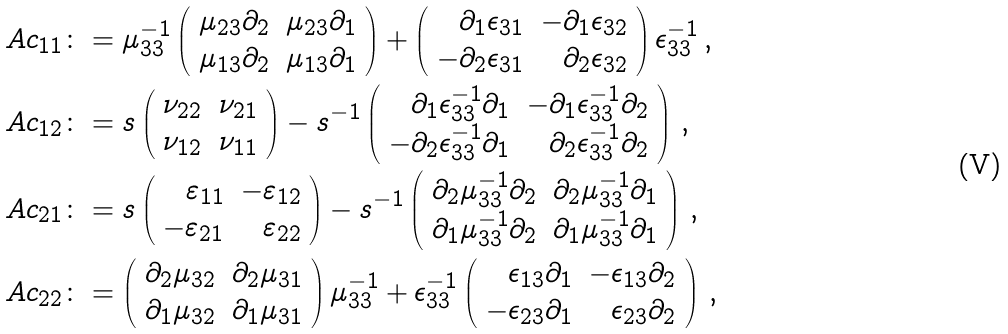<formula> <loc_0><loc_0><loc_500><loc_500>\ A c _ { 1 1 } & \colon = \mu _ { 3 3 } ^ { - 1 } \left ( \begin{array} { r r } \mu _ { 2 3 } \partial _ { 2 } & \mu _ { 2 3 } \partial _ { 1 } \\ \mu _ { 1 3 } \partial _ { 2 } & \mu _ { 1 3 } \partial _ { 1 } \end{array} \right ) + \left ( \begin{array} { r r } \partial _ { 1 } \epsilon _ { 3 1 } & - \partial _ { 1 } \epsilon _ { 3 2 } \\ - \partial _ { 2 } \epsilon _ { 3 1 } & \partial _ { 2 } \epsilon _ { 3 2 } \end{array} \right ) \epsilon _ { 3 3 } ^ { - 1 } \, , \\ \ A c _ { 1 2 } & \colon = s \left ( \begin{array} { r r } \nu _ { 2 2 } & \nu _ { 2 1 } \\ \nu _ { 1 2 } & \nu _ { 1 1 } \end{array} \right ) - s ^ { - 1 } \left ( \begin{array} { r r } \partial _ { 1 } \epsilon _ { 3 3 } ^ { - 1 } \partial _ { 1 } & - \partial _ { 1 } \epsilon _ { 3 3 } ^ { - 1 } \partial _ { 2 } \\ - \partial _ { 2 } \epsilon _ { 3 3 } ^ { - 1 } \partial _ { 1 } & \partial _ { 2 } \epsilon _ { 3 3 } ^ { - 1 } \partial _ { 2 } \end{array} \right ) \, , \\ \ A c _ { 2 1 } & \colon = s \left ( \begin{array} { r r } \varepsilon _ { 1 1 } & - \varepsilon _ { 1 2 } \\ - \varepsilon _ { 2 1 } & \varepsilon _ { 2 2 } \end{array} \right ) - s ^ { - 1 } \left ( \begin{array} { r r } \partial _ { 2 } \mu _ { 3 3 } ^ { - 1 } \partial _ { 2 } & \partial _ { 2 } \mu _ { 3 3 } ^ { - 1 } \partial _ { 1 } \\ \partial _ { 1 } \mu _ { 3 3 } ^ { - 1 } \partial _ { 2 } & \partial _ { 1 } \mu _ { 3 3 } ^ { - 1 } \partial _ { 1 } \end{array} \right ) \, , \\ \ A c _ { 2 2 } & \colon = \left ( \begin{array} { r r } \partial _ { 2 } \mu _ { 3 2 } & \partial _ { 2 } \mu _ { 3 1 } \\ \partial _ { 1 } \mu _ { 3 2 } & \partial _ { 1 } \mu _ { 3 1 } \end{array} \right ) \mu _ { 3 3 } ^ { - 1 } + \epsilon _ { 3 3 } ^ { - 1 } \left ( \begin{array} { r r } \epsilon _ { 1 3 } \partial _ { 1 } & - \epsilon _ { 1 3 } \partial _ { 2 } \\ - \epsilon _ { 2 3 } \partial _ { 1 } & \epsilon _ { 2 3 } \partial _ { 2 } \end{array} \right ) \, ,</formula> 